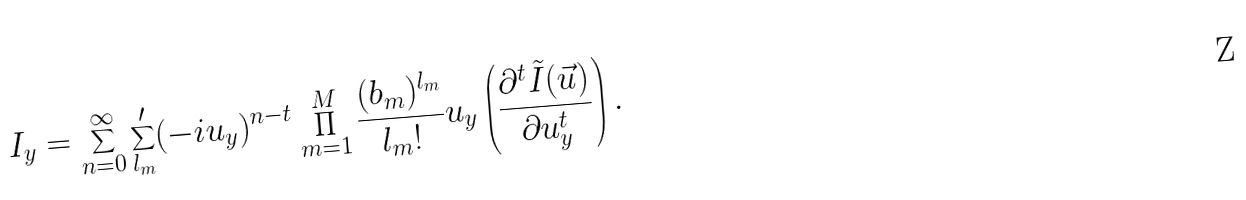<formula> <loc_0><loc_0><loc_500><loc_500>I _ { y } = \sum _ { n = 0 } ^ { \infty } \sum _ { l _ { m } } ^ { \prime } ( - i u _ { y } ) ^ { n - t } \prod _ { m = 1 } ^ { M } \frac { ( b _ { m } ) ^ { l _ { m } } } { l _ { m } ! } u _ { y } \left ( \frac { \partial ^ { t } \tilde { I } ( \vec { u } ) } { \partial u _ { y } ^ { t } } \right ) .</formula> 